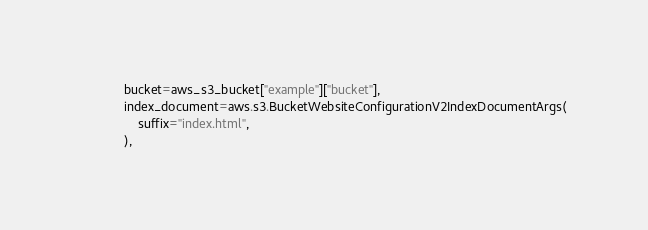Convert code to text. <code><loc_0><loc_0><loc_500><loc_500><_Python_>            bucket=aws_s3_bucket["example"]["bucket"],
            index_document=aws.s3.BucketWebsiteConfigurationV2IndexDocumentArgs(
                suffix="index.html",
            ),</code> 